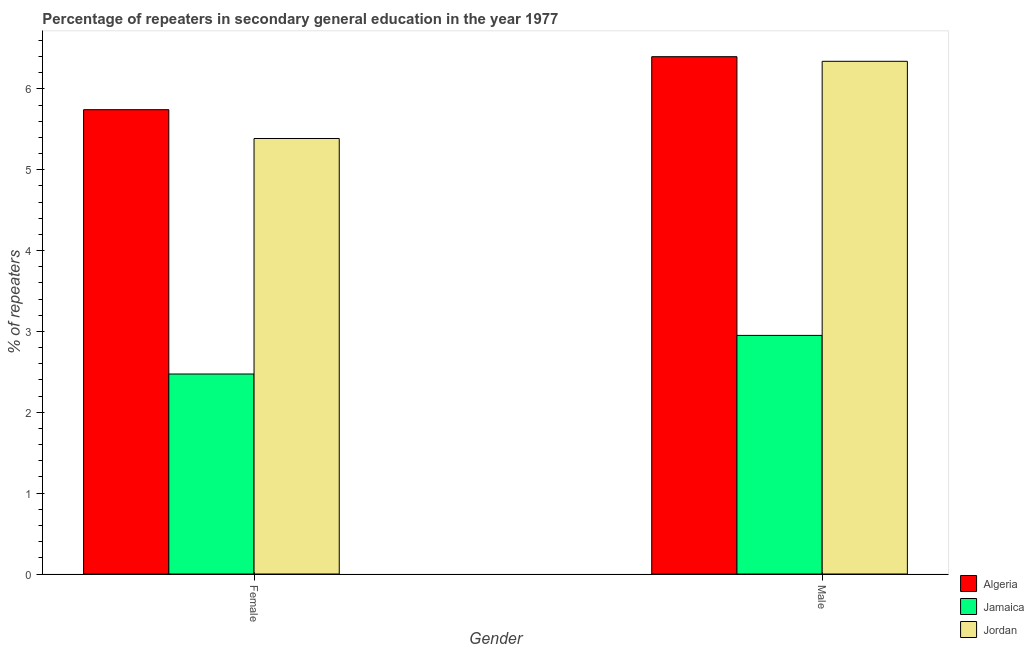How many bars are there on the 1st tick from the left?
Your response must be concise. 3. How many bars are there on the 1st tick from the right?
Offer a very short reply. 3. What is the label of the 2nd group of bars from the left?
Offer a terse response. Male. What is the percentage of female repeaters in Algeria?
Provide a succinct answer. 5.74. Across all countries, what is the maximum percentage of female repeaters?
Make the answer very short. 5.74. Across all countries, what is the minimum percentage of male repeaters?
Keep it short and to the point. 2.95. In which country was the percentage of female repeaters maximum?
Offer a very short reply. Algeria. In which country was the percentage of female repeaters minimum?
Your answer should be very brief. Jamaica. What is the total percentage of male repeaters in the graph?
Provide a short and direct response. 15.69. What is the difference between the percentage of male repeaters in Algeria and that in Jamaica?
Offer a terse response. 3.45. What is the difference between the percentage of male repeaters in Algeria and the percentage of female repeaters in Jamaica?
Your answer should be very brief. 3.92. What is the average percentage of female repeaters per country?
Offer a very short reply. 4.53. What is the difference between the percentage of female repeaters and percentage of male repeaters in Jamaica?
Provide a short and direct response. -0.48. What is the ratio of the percentage of male repeaters in Jordan to that in Algeria?
Give a very brief answer. 0.99. In how many countries, is the percentage of male repeaters greater than the average percentage of male repeaters taken over all countries?
Ensure brevity in your answer.  2. What does the 1st bar from the left in Male represents?
Your answer should be compact. Algeria. What does the 1st bar from the right in Male represents?
Your response must be concise. Jordan. What is the difference between two consecutive major ticks on the Y-axis?
Your answer should be compact. 1. Are the values on the major ticks of Y-axis written in scientific E-notation?
Make the answer very short. No. Does the graph contain grids?
Your response must be concise. No. Where does the legend appear in the graph?
Keep it short and to the point. Bottom right. How many legend labels are there?
Give a very brief answer. 3. How are the legend labels stacked?
Give a very brief answer. Vertical. What is the title of the graph?
Offer a very short reply. Percentage of repeaters in secondary general education in the year 1977. What is the label or title of the X-axis?
Provide a short and direct response. Gender. What is the label or title of the Y-axis?
Offer a very short reply. % of repeaters. What is the % of repeaters of Algeria in Female?
Offer a terse response. 5.74. What is the % of repeaters in Jamaica in Female?
Your answer should be very brief. 2.47. What is the % of repeaters in Jordan in Female?
Offer a terse response. 5.39. What is the % of repeaters in Algeria in Male?
Make the answer very short. 6.4. What is the % of repeaters in Jamaica in Male?
Make the answer very short. 2.95. What is the % of repeaters in Jordan in Male?
Provide a short and direct response. 6.34. Across all Gender, what is the maximum % of repeaters of Algeria?
Ensure brevity in your answer.  6.4. Across all Gender, what is the maximum % of repeaters in Jamaica?
Keep it short and to the point. 2.95. Across all Gender, what is the maximum % of repeaters of Jordan?
Your answer should be very brief. 6.34. Across all Gender, what is the minimum % of repeaters of Algeria?
Provide a succinct answer. 5.74. Across all Gender, what is the minimum % of repeaters in Jamaica?
Offer a terse response. 2.47. Across all Gender, what is the minimum % of repeaters in Jordan?
Keep it short and to the point. 5.39. What is the total % of repeaters in Algeria in the graph?
Keep it short and to the point. 12.14. What is the total % of repeaters of Jamaica in the graph?
Give a very brief answer. 5.42. What is the total % of repeaters in Jordan in the graph?
Make the answer very short. 11.73. What is the difference between the % of repeaters of Algeria in Female and that in Male?
Your answer should be very brief. -0.66. What is the difference between the % of repeaters of Jamaica in Female and that in Male?
Your response must be concise. -0.48. What is the difference between the % of repeaters in Jordan in Female and that in Male?
Make the answer very short. -0.95. What is the difference between the % of repeaters of Algeria in Female and the % of repeaters of Jamaica in Male?
Your response must be concise. 2.79. What is the difference between the % of repeaters in Algeria in Female and the % of repeaters in Jordan in Male?
Ensure brevity in your answer.  -0.6. What is the difference between the % of repeaters in Jamaica in Female and the % of repeaters in Jordan in Male?
Make the answer very short. -3.87. What is the average % of repeaters in Algeria per Gender?
Ensure brevity in your answer.  6.07. What is the average % of repeaters in Jamaica per Gender?
Offer a terse response. 2.71. What is the average % of repeaters in Jordan per Gender?
Your answer should be very brief. 5.86. What is the difference between the % of repeaters in Algeria and % of repeaters in Jamaica in Female?
Your answer should be compact. 3.27. What is the difference between the % of repeaters in Algeria and % of repeaters in Jordan in Female?
Give a very brief answer. 0.36. What is the difference between the % of repeaters of Jamaica and % of repeaters of Jordan in Female?
Offer a very short reply. -2.91. What is the difference between the % of repeaters in Algeria and % of repeaters in Jamaica in Male?
Ensure brevity in your answer.  3.45. What is the difference between the % of repeaters in Algeria and % of repeaters in Jordan in Male?
Make the answer very short. 0.06. What is the difference between the % of repeaters in Jamaica and % of repeaters in Jordan in Male?
Make the answer very short. -3.39. What is the ratio of the % of repeaters of Algeria in Female to that in Male?
Provide a short and direct response. 0.9. What is the ratio of the % of repeaters of Jamaica in Female to that in Male?
Your response must be concise. 0.84. What is the ratio of the % of repeaters in Jordan in Female to that in Male?
Keep it short and to the point. 0.85. What is the difference between the highest and the second highest % of repeaters of Algeria?
Keep it short and to the point. 0.66. What is the difference between the highest and the second highest % of repeaters of Jamaica?
Make the answer very short. 0.48. What is the difference between the highest and the second highest % of repeaters in Jordan?
Your response must be concise. 0.95. What is the difference between the highest and the lowest % of repeaters in Algeria?
Give a very brief answer. 0.66. What is the difference between the highest and the lowest % of repeaters of Jamaica?
Provide a succinct answer. 0.48. What is the difference between the highest and the lowest % of repeaters of Jordan?
Your response must be concise. 0.95. 